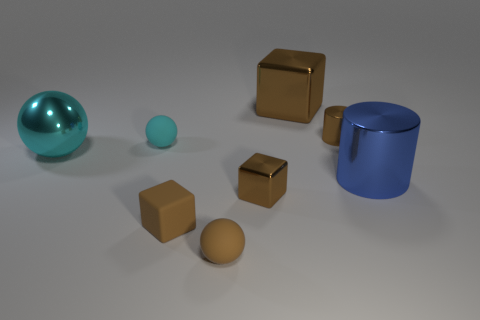There is another matte ball that is the same color as the big sphere; what is its size?
Offer a very short reply. Small. How many things have the same color as the big metallic sphere?
Keep it short and to the point. 1. What color is the large metallic object that is the same shape as the cyan rubber object?
Your answer should be very brief. Cyan. Is there anything else that has the same shape as the large blue metallic thing?
Ensure brevity in your answer.  Yes. There is a cyan metal object; is its shape the same as the tiny rubber thing behind the large blue thing?
Make the answer very short. Yes. There is another cyan object that is the same shape as the tiny cyan object; what is its size?
Your answer should be compact. Large. What number of other objects are the same material as the small cylinder?
Provide a short and direct response. 4. Does the brown cylinder have the same material as the small sphere behind the blue metal cylinder?
Provide a succinct answer. No. Are there fewer big brown metal cubes left of the large metallic sphere than brown shiny things that are on the left side of the big brown metal object?
Keep it short and to the point. Yes. There is a metal block that is in front of the large blue cylinder; what is its color?
Keep it short and to the point. Brown. 